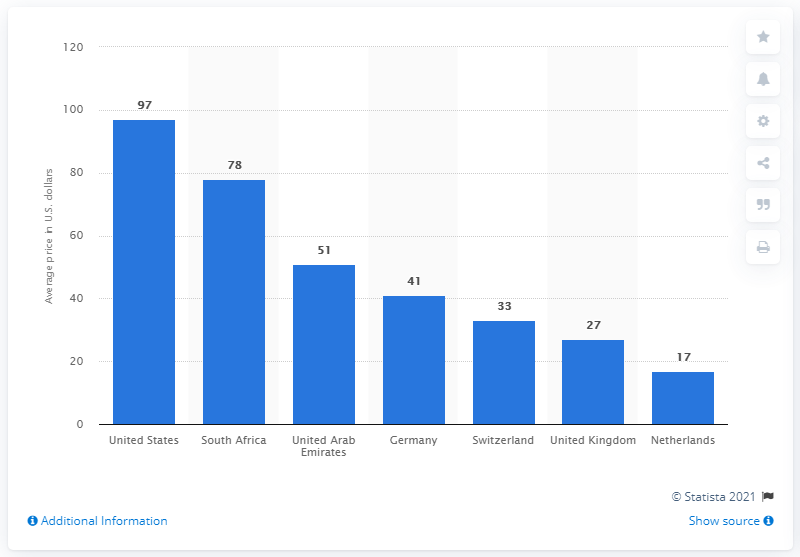Specify some key components in this picture. In the United States in 2017, the average price of an immune globulin injection was approximately $97. 